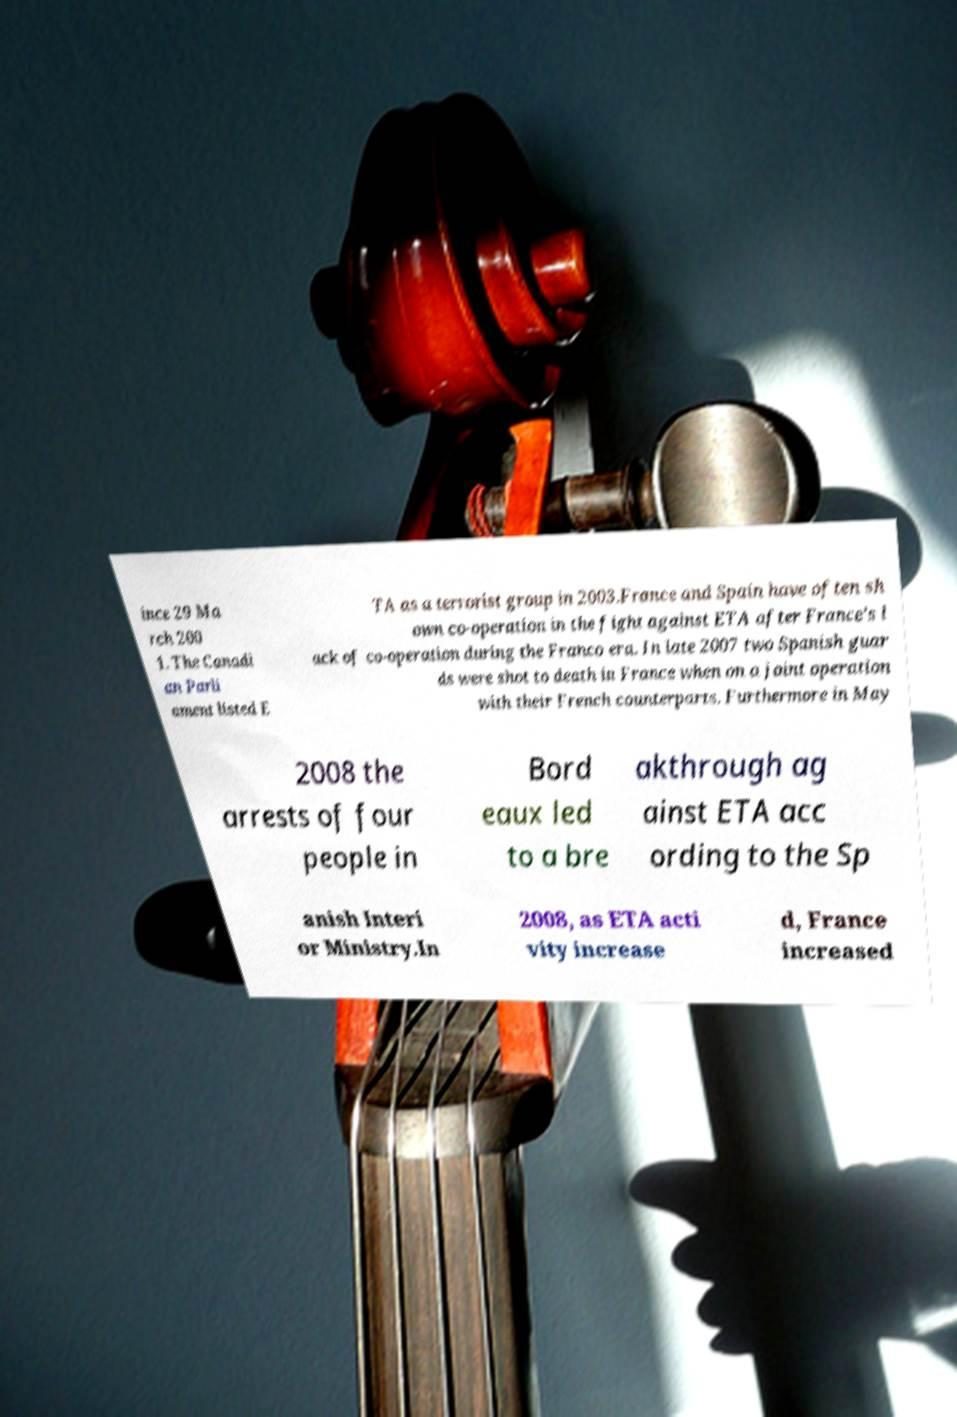Could you assist in decoding the text presented in this image and type it out clearly? ince 29 Ma rch 200 1. The Canadi an Parli ament listed E TA as a terrorist group in 2003.France and Spain have often sh own co-operation in the fight against ETA after France's l ack of co-operation during the Franco era. In late 2007 two Spanish guar ds were shot to death in France when on a joint operation with their French counterparts. Furthermore in May 2008 the arrests of four people in Bord eaux led to a bre akthrough ag ainst ETA acc ording to the Sp anish Interi or Ministry.In 2008, as ETA acti vity increase d, France increased 